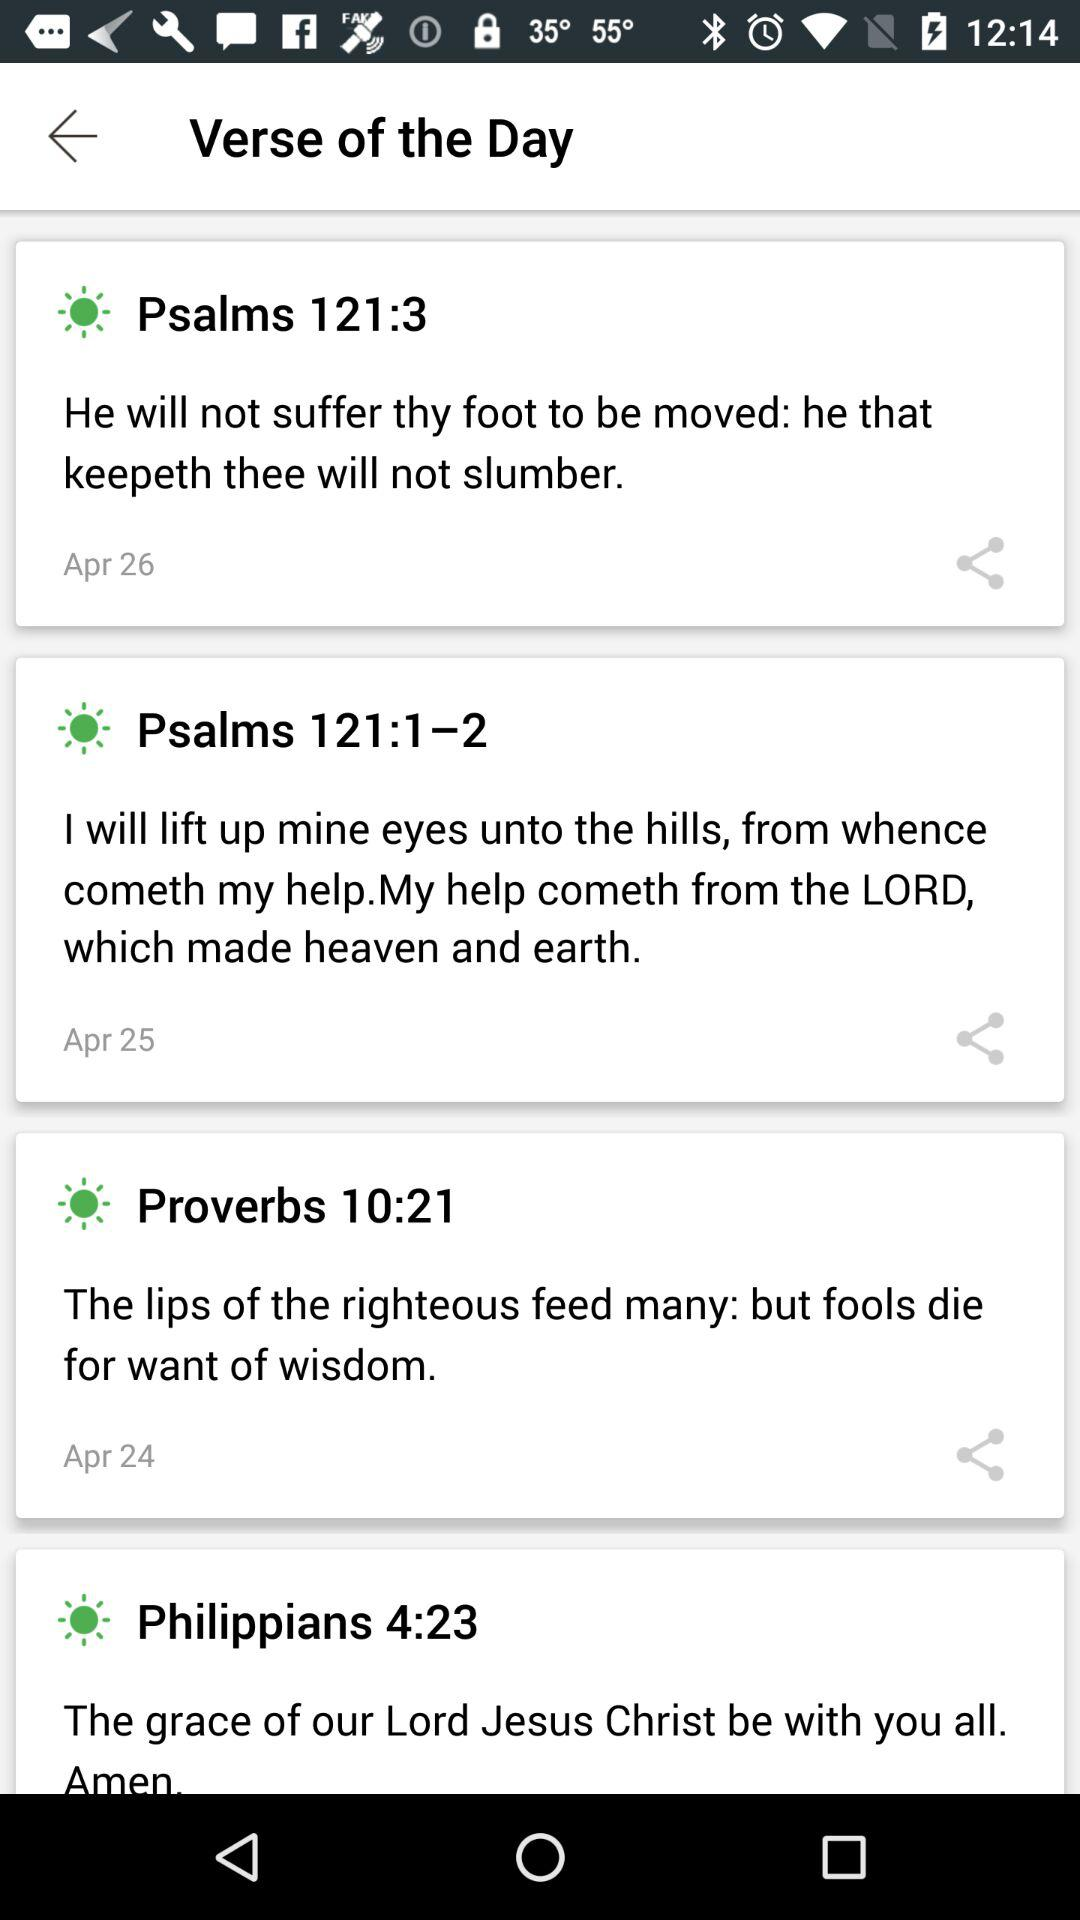Which Bible version is this?
When the provided information is insufficient, respond with <no answer>. <no answer> 